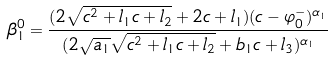<formula> <loc_0><loc_0><loc_500><loc_500>\beta _ { 1 } ^ { 0 } = \frac { ( 2 \sqrt { c ^ { 2 } + l _ { 1 } c + l _ { 2 } } + 2 c + l _ { 1 } ) ( c - \varphi _ { 0 } ^ { - } ) ^ { \alpha _ { 1 } } } { ( 2 \sqrt { a _ { 1 } } \sqrt { c ^ { 2 } + l _ { 1 } c + l _ { 2 } } + b _ { 1 } c + l _ { 3 } ) ^ { \alpha _ { 1 } } }</formula> 